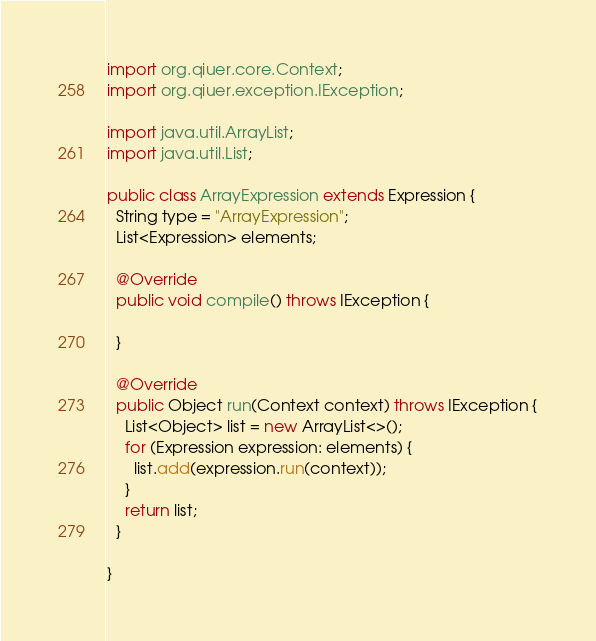Convert code to text. <code><loc_0><loc_0><loc_500><loc_500><_Java_>import org.qiuer.core.Context;
import org.qiuer.exception.IException;

import java.util.ArrayList;
import java.util.List;

public class ArrayExpression extends Expression {
  String type = "ArrayExpression";
  List<Expression> elements;

  @Override
  public void compile() throws IException {

  }

  @Override
  public Object run(Context context) throws IException {
    List<Object> list = new ArrayList<>();
    for (Expression expression: elements) {
      list.add(expression.run(context));
    }
    return list;
  }

}
</code> 